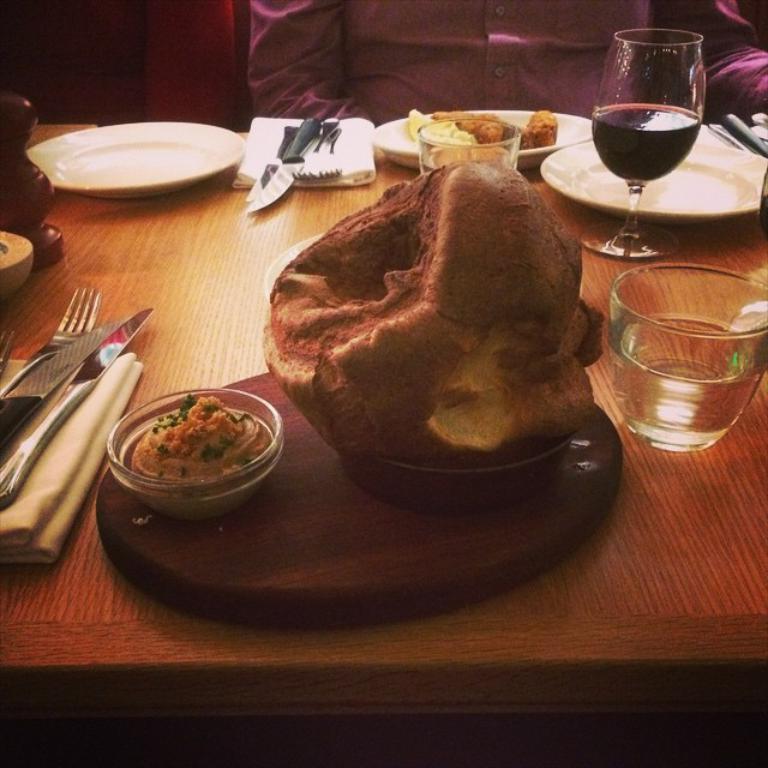Could you give a brief overview of what you see in this image? In this image, I can see the plates, knives, forks, napkins, glasses, food items and few other objects on the table. In the background, I can see a person sitting. 